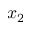Convert formula to latex. <formula><loc_0><loc_0><loc_500><loc_500>x _ { 2 }</formula> 